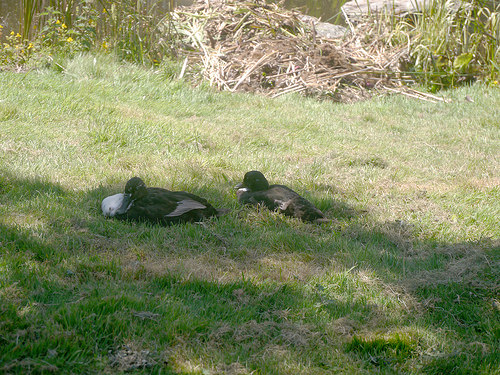<image>
Can you confirm if the duck is in the water? No. The duck is not contained within the water. These objects have a different spatial relationship. Is the duck above the grass? No. The duck is not positioned above the grass. The vertical arrangement shows a different relationship. Is there a duck on the grass? Yes. Looking at the image, I can see the duck is positioned on top of the grass, with the grass providing support. 